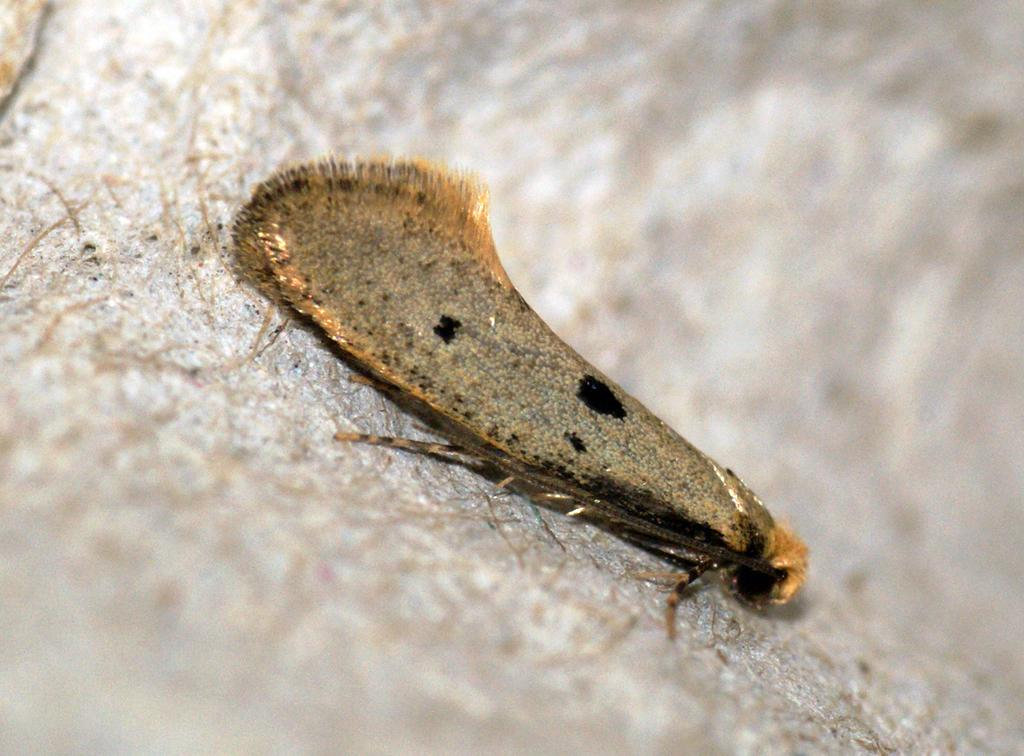What type of creature can be seen in the image? There is an insect in the image. Where is the insect located in the image? The insect is on a surface. What is the hour of the day depicted in the image? The provided facts do not mention the time of day, so it cannot be determined from the image. 